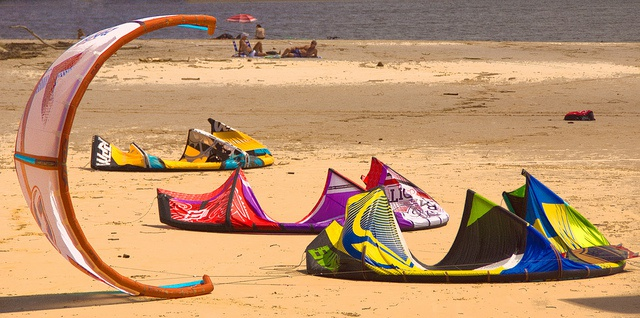Describe the objects in this image and their specific colors. I can see kite in black, gold, navy, and olive tones, kite in black, salmon, maroon, and brown tones, kite in black, red, white, brown, and maroon tones, kite in black, orange, olive, and maroon tones, and people in black, maroon, brown, and gray tones in this image. 